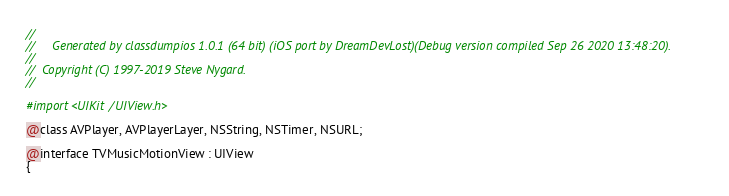<code> <loc_0><loc_0><loc_500><loc_500><_C_>//
//     Generated by classdumpios 1.0.1 (64 bit) (iOS port by DreamDevLost)(Debug version compiled Sep 26 2020 13:48:20).
//
//  Copyright (C) 1997-2019 Steve Nygard.
//

#import <UIKit/UIView.h>

@class AVPlayer, AVPlayerLayer, NSString, NSTimer, NSURL;

@interface TVMusicMotionView : UIView
{</code> 